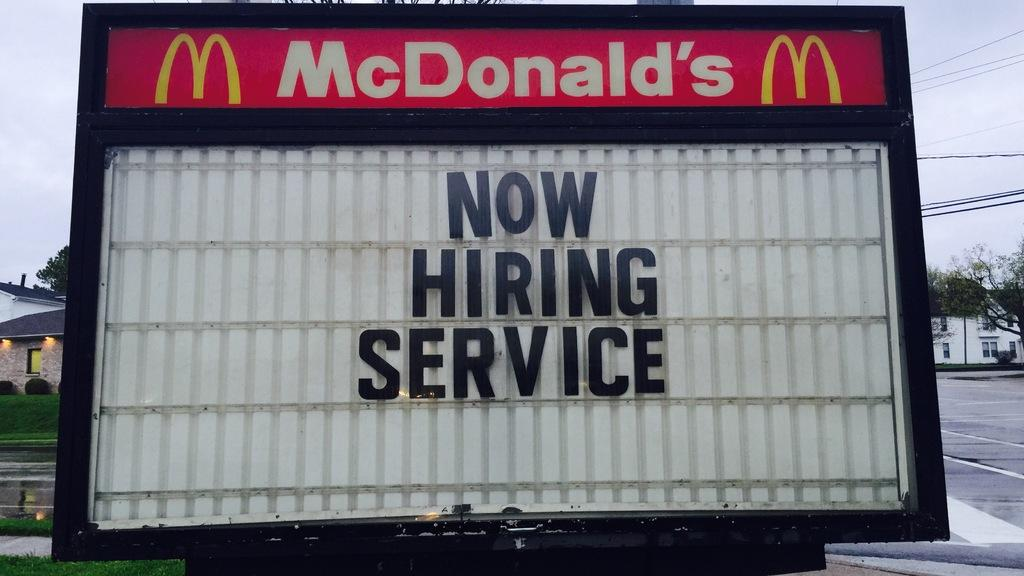<image>
Describe the image concisely. Now hiring service is place on a red, white, yellow and black McDonald's sign. 